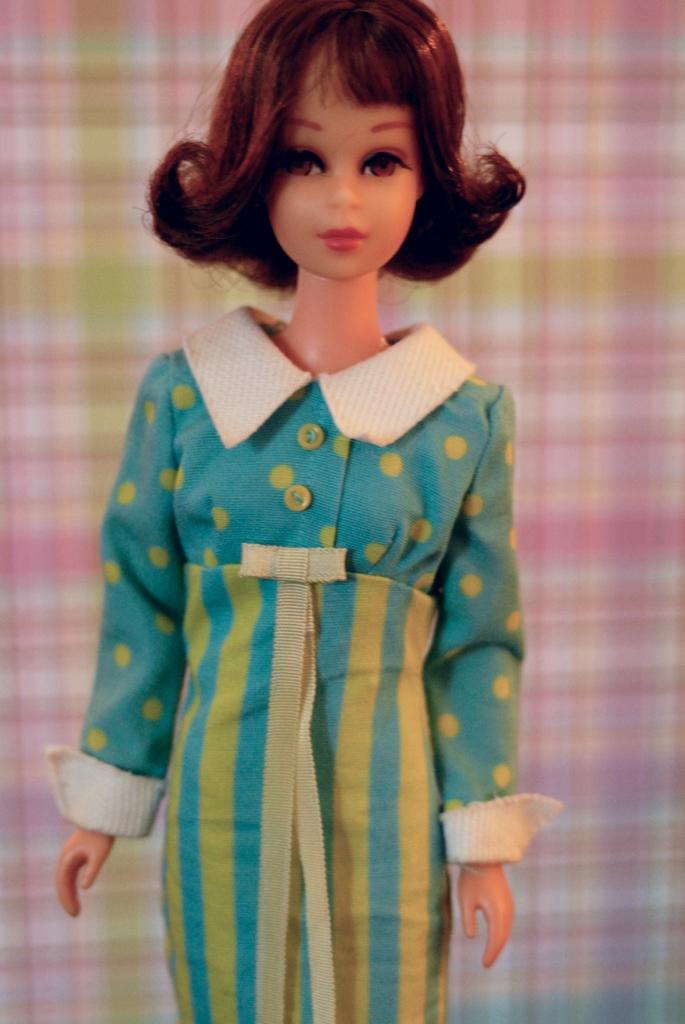What is the main subject of the picture? The main subject of the picture is a Barbie doll. What is the Barbie doll wearing? The Barbie doll is wearing a blue dress. Can you describe the design of the blue dress? The blue dress has yellow color dots and lines on it. What can be seen in the background of the picture? There is a cloth visible in the background of the picture. What type of cheese is being used to decorate the Barbie doll's dress in the image? There is no cheese present in the image, and the Barbie doll's dress does not have any cheese decorations. 